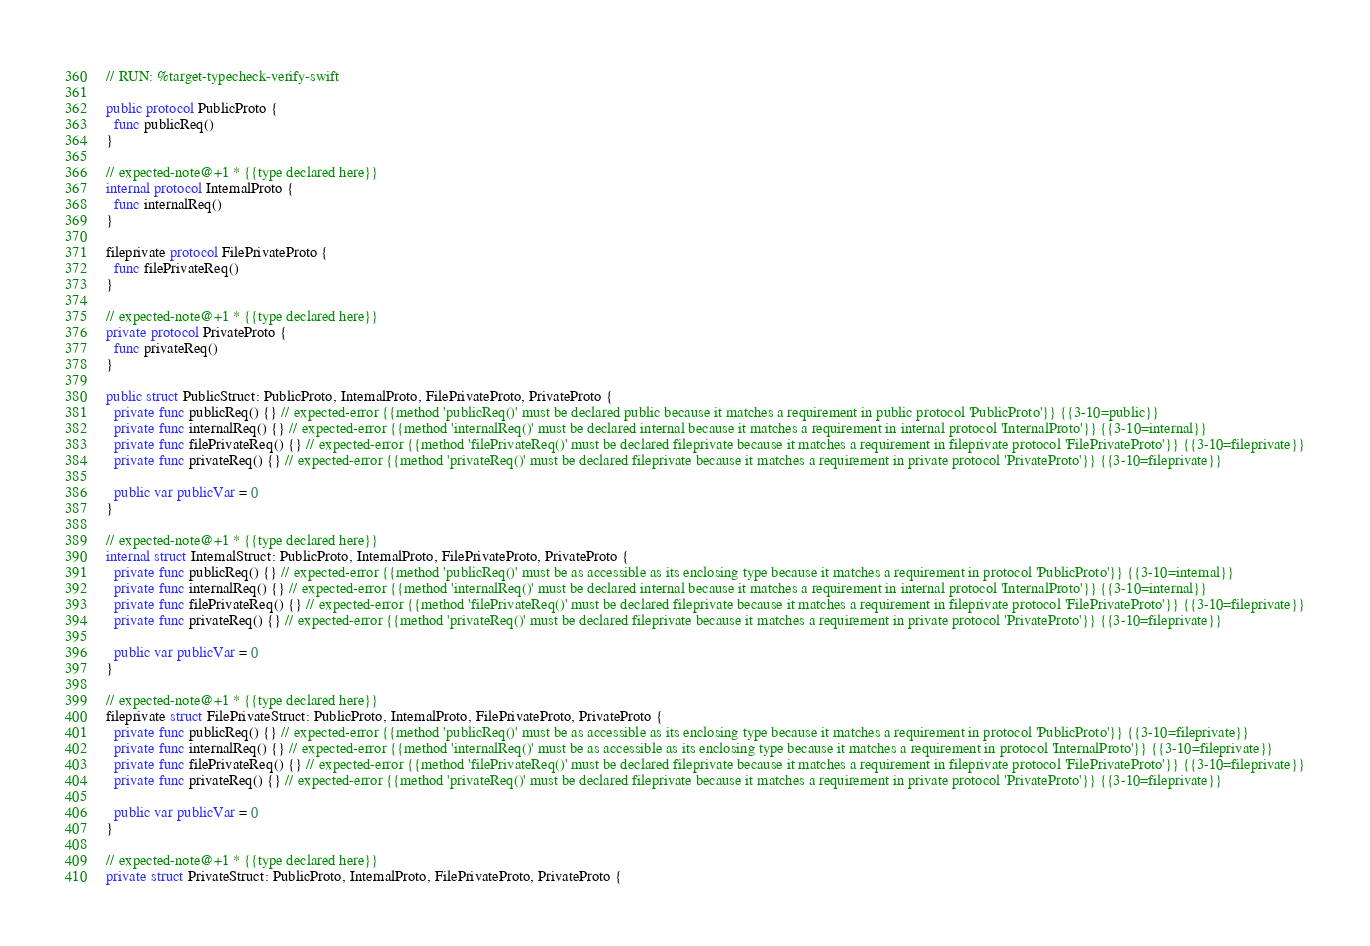<code> <loc_0><loc_0><loc_500><loc_500><_Swift_>// RUN: %target-typecheck-verify-swift

public protocol PublicProto {
  func publicReq()
}

// expected-note@+1 * {{type declared here}}
internal protocol InternalProto {
  func internalReq()
}

fileprivate protocol FilePrivateProto {
  func filePrivateReq()
}

// expected-note@+1 * {{type declared here}}
private protocol PrivateProto {
  func privateReq()
}

public struct PublicStruct: PublicProto, InternalProto, FilePrivateProto, PrivateProto {
  private func publicReq() {} // expected-error {{method 'publicReq()' must be declared public because it matches a requirement in public protocol 'PublicProto'}} {{3-10=public}}
  private func internalReq() {} // expected-error {{method 'internalReq()' must be declared internal because it matches a requirement in internal protocol 'InternalProto'}} {{3-10=internal}}
  private func filePrivateReq() {} // expected-error {{method 'filePrivateReq()' must be declared fileprivate because it matches a requirement in fileprivate protocol 'FilePrivateProto'}} {{3-10=fileprivate}}
  private func privateReq() {} // expected-error {{method 'privateReq()' must be declared fileprivate because it matches a requirement in private protocol 'PrivateProto'}} {{3-10=fileprivate}}

  public var publicVar = 0
}

// expected-note@+1 * {{type declared here}}
internal struct InternalStruct: PublicProto, InternalProto, FilePrivateProto, PrivateProto {
  private func publicReq() {} // expected-error {{method 'publicReq()' must be as accessible as its enclosing type because it matches a requirement in protocol 'PublicProto'}} {{3-10=internal}}
  private func internalReq() {} // expected-error {{method 'internalReq()' must be declared internal because it matches a requirement in internal protocol 'InternalProto'}} {{3-10=internal}}
  private func filePrivateReq() {} // expected-error {{method 'filePrivateReq()' must be declared fileprivate because it matches a requirement in fileprivate protocol 'FilePrivateProto'}} {{3-10=fileprivate}}
  private func privateReq() {} // expected-error {{method 'privateReq()' must be declared fileprivate because it matches a requirement in private protocol 'PrivateProto'}} {{3-10=fileprivate}}

  public var publicVar = 0
}

// expected-note@+1 * {{type declared here}}
fileprivate struct FilePrivateStruct: PublicProto, InternalProto, FilePrivateProto, PrivateProto {
  private func publicReq() {} // expected-error {{method 'publicReq()' must be as accessible as its enclosing type because it matches a requirement in protocol 'PublicProto'}} {{3-10=fileprivate}}
  private func internalReq() {} // expected-error {{method 'internalReq()' must be as accessible as its enclosing type because it matches a requirement in protocol 'InternalProto'}} {{3-10=fileprivate}}
  private func filePrivateReq() {} // expected-error {{method 'filePrivateReq()' must be declared fileprivate because it matches a requirement in fileprivate protocol 'FilePrivateProto'}} {{3-10=fileprivate}}
  private func privateReq() {} // expected-error {{method 'privateReq()' must be declared fileprivate because it matches a requirement in private protocol 'PrivateProto'}} {{3-10=fileprivate}}

  public var publicVar = 0
}

// expected-note@+1 * {{type declared here}}
private struct PrivateStruct: PublicProto, InternalProto, FilePrivateProto, PrivateProto {</code> 